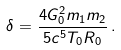Convert formula to latex. <formula><loc_0><loc_0><loc_500><loc_500>\delta = \frac { 4 G _ { 0 } ^ { 2 } m _ { 1 } m _ { 2 } } { 5 c ^ { 5 } T _ { 0 } R _ { 0 } } \, .</formula> 